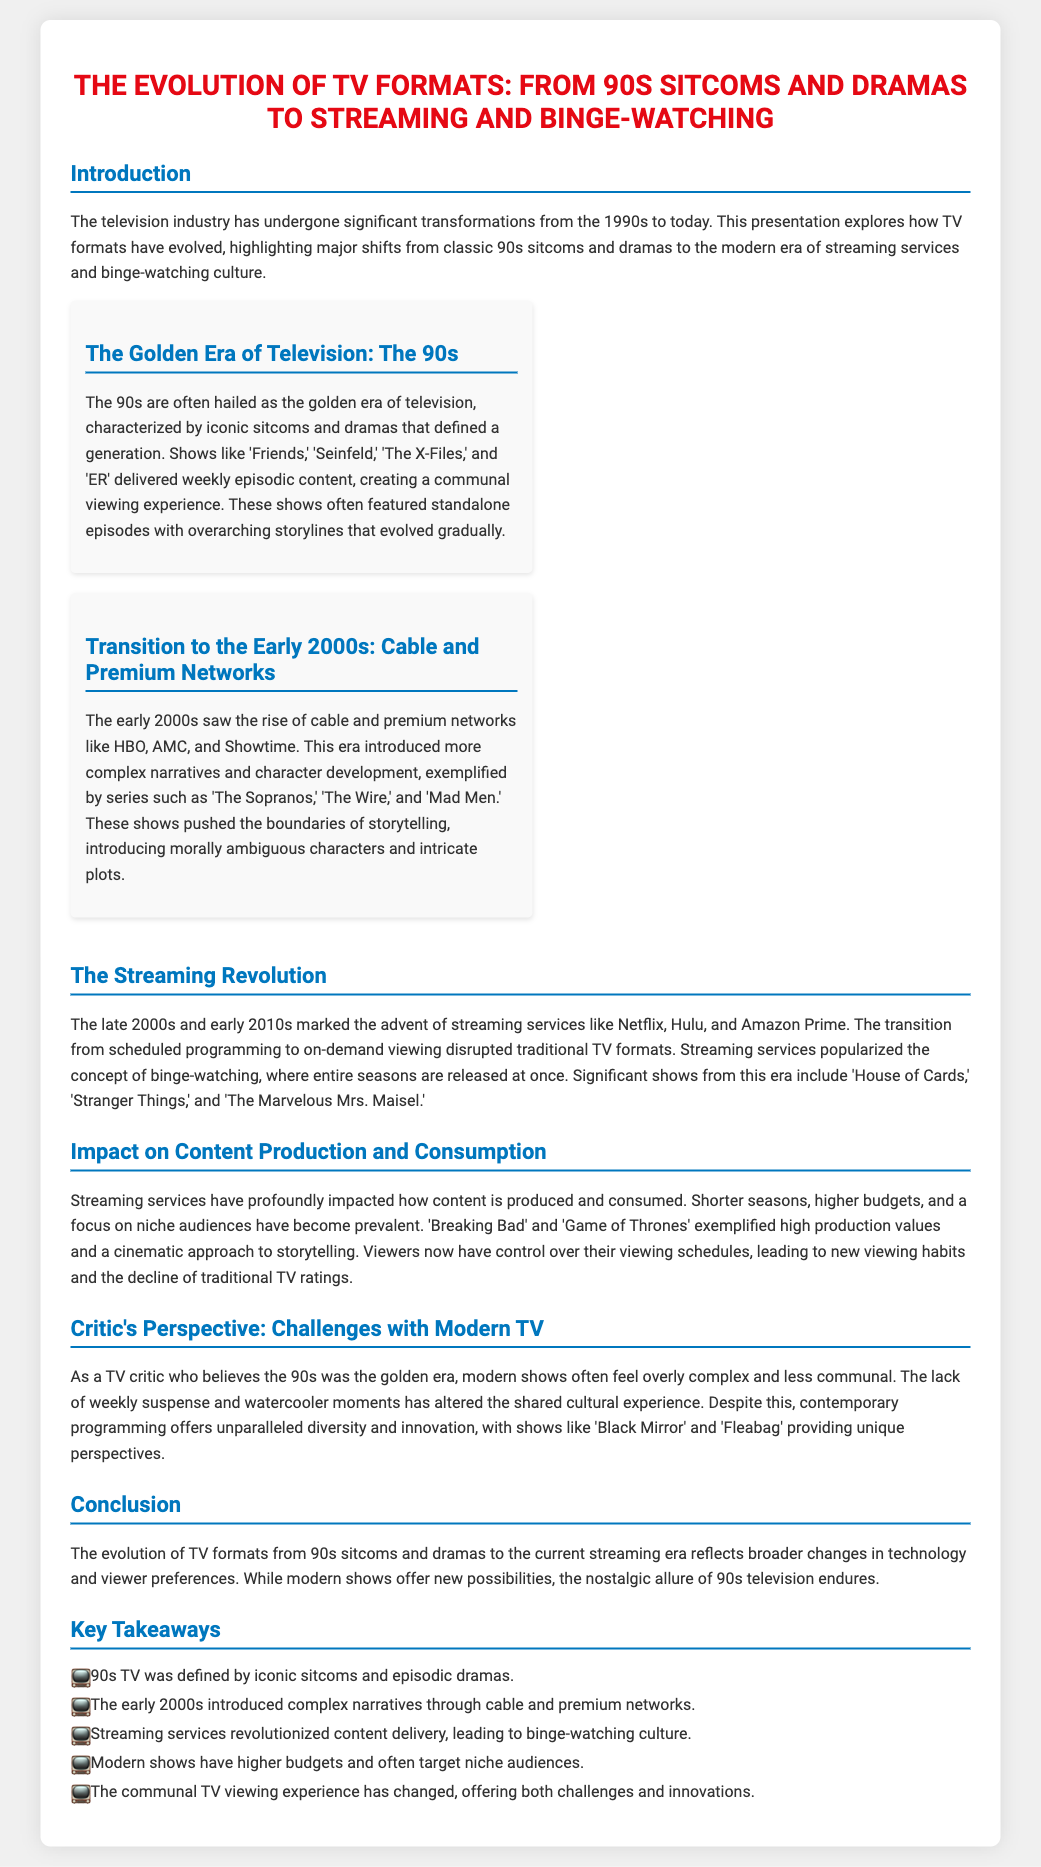What are some iconic shows from the 90s? The document lists 'Friends,' 'Seinfeld,' 'The X-Files,' and 'ER' as iconic 90s shows.
Answer: Friends, Seinfeld, The X-Files, ER Which networks rose to prominence in the early 2000s? The document mentions HBO, AMC, and Showtime as prominent networks in the early 2000s.
Answer: HBO, AMC, Showtime What viewing experience did 90s television create? The document states that 90s television created a communal viewing experience through weekly episodic content.
Answer: Communal viewing experience What major shift did streaming services introduce? The document explains that streaming services disrupted traditional TV formats by introducing on-demand viewing.
Answer: On-demand viewing Name a show that exemplified high production values in modern TV. The document cites 'Breaking Bad' as a show that exemplified high production values.
Answer: Breaking Bad How did modern shows affect viewing habits? The document indicates that viewers now have control over their viewing schedules, leading to new viewing habits.
Answer: Control over viewing schedules What is a characteristic of contemporary programming mentioned? The document notes that contemporary programming often features shorter seasons and higher budgets.
Answer: Shorter seasons, higher budgets What key concept did streaming services popularize? The document states that streaming services popularized the concept of binge-watching.
Answer: Binge-watching How does the critic perceive modern TV shows? The document describes the critic's view as finding modern shows overly complex and less communal.
Answer: Overly complex and less communal 